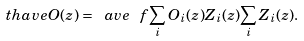<formula> <loc_0><loc_0><loc_500><loc_500>\ t h a v e { O ( z ) } = \ a v e { \ f { \sum _ { i } O _ { i } ( z ) Z _ { i } ( z ) } { \sum _ { i } Z _ { i } ( z ) } } .</formula> 